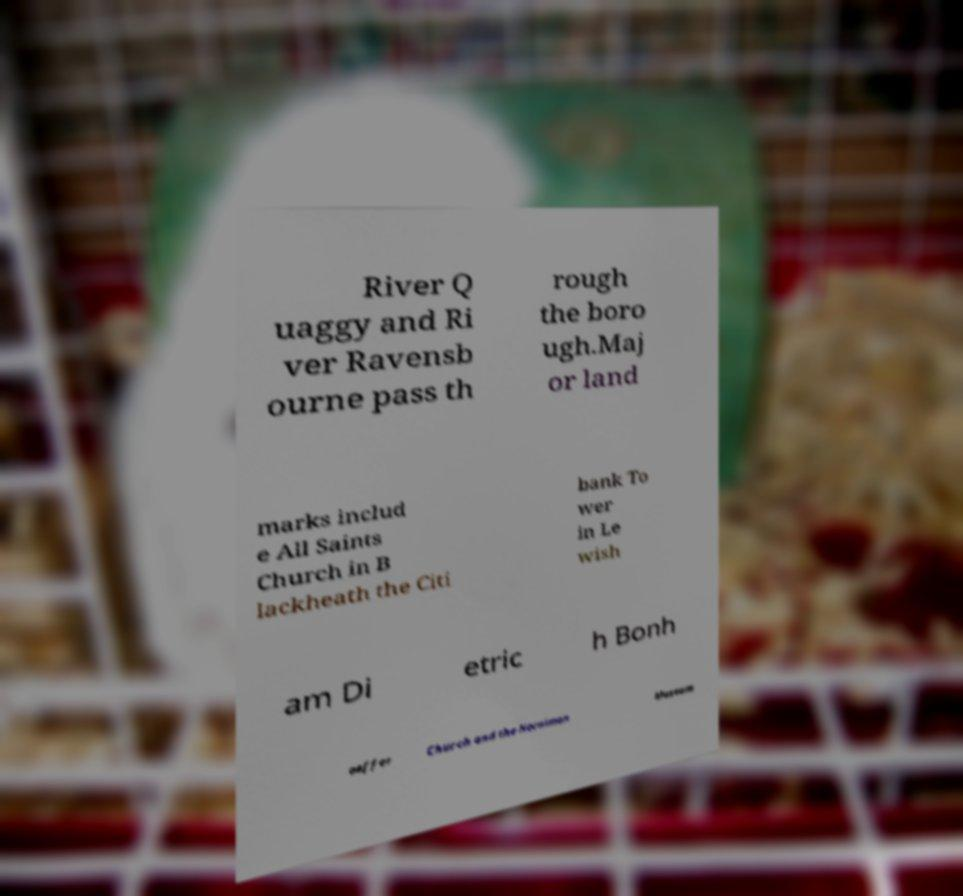Can you read and provide the text displayed in the image?This photo seems to have some interesting text. Can you extract and type it out for me? River Q uaggy and Ri ver Ravensb ourne pass th rough the boro ugh.Maj or land marks includ e All Saints Church in B lackheath the Citi bank To wer in Le wish am Di etric h Bonh oeffer Church and the Horniman Museum 